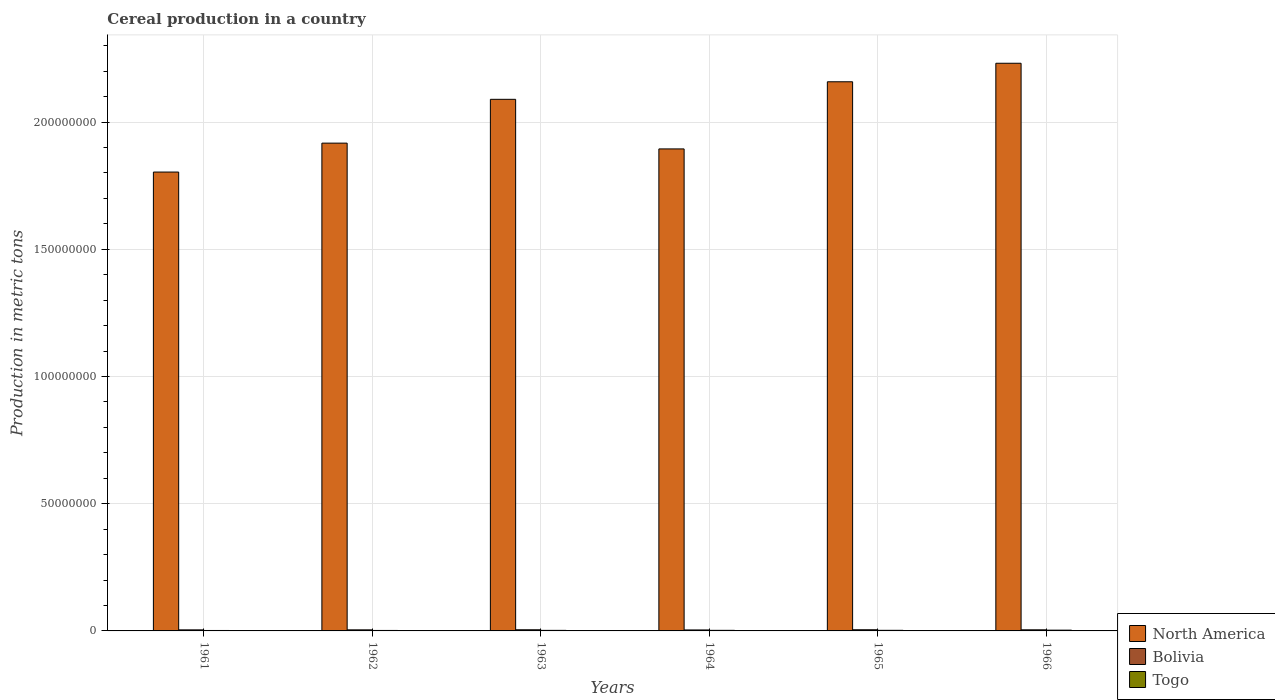How many different coloured bars are there?
Provide a succinct answer. 3. How many groups of bars are there?
Offer a terse response. 6. How many bars are there on the 4th tick from the left?
Ensure brevity in your answer.  3. How many bars are there on the 4th tick from the right?
Offer a very short reply. 3. In how many cases, is the number of bars for a given year not equal to the number of legend labels?
Offer a very short reply. 0. What is the total cereal production in Togo in 1966?
Give a very brief answer. 3.03e+05. Across all years, what is the maximum total cereal production in North America?
Offer a very short reply. 2.23e+08. Across all years, what is the minimum total cereal production in Bolivia?
Provide a succinct answer. 3.81e+05. In which year was the total cereal production in Bolivia maximum?
Keep it short and to the point. 1965. In which year was the total cereal production in Bolivia minimum?
Offer a terse response. 1964. What is the total total cereal production in North America in the graph?
Offer a very short reply. 1.21e+09. What is the difference between the total cereal production in Togo in 1965 and that in 1966?
Keep it short and to the point. -6.55e+04. What is the difference between the total cereal production in North America in 1965 and the total cereal production in Togo in 1962?
Offer a terse response. 2.16e+08. What is the average total cereal production in Togo per year?
Provide a succinct answer. 2.25e+05. In the year 1962, what is the difference between the total cereal production in Bolivia and total cereal production in Togo?
Offer a terse response. 2.33e+05. In how many years, is the total cereal production in North America greater than 110000000 metric tons?
Your answer should be compact. 6. What is the ratio of the total cereal production in Togo in 1963 to that in 1964?
Your answer should be very brief. 0.97. Is the total cereal production in North America in 1961 less than that in 1964?
Your response must be concise. Yes. What is the difference between the highest and the second highest total cereal production in Togo?
Your answer should be compact. 6.55e+04. What is the difference between the highest and the lowest total cereal production in North America?
Your response must be concise. 4.28e+07. Is the sum of the total cereal production in North America in 1961 and 1962 greater than the maximum total cereal production in Togo across all years?
Offer a terse response. Yes. What does the 3rd bar from the left in 1966 represents?
Offer a terse response. Togo. Is it the case that in every year, the sum of the total cereal production in North America and total cereal production in Togo is greater than the total cereal production in Bolivia?
Offer a very short reply. Yes. Are all the bars in the graph horizontal?
Provide a short and direct response. No. Are the values on the major ticks of Y-axis written in scientific E-notation?
Make the answer very short. No. How many legend labels are there?
Make the answer very short. 3. What is the title of the graph?
Provide a succinct answer. Cereal production in a country. What is the label or title of the X-axis?
Give a very brief answer. Years. What is the label or title of the Y-axis?
Offer a very short reply. Production in metric tons. What is the Production in metric tons of North America in 1961?
Your response must be concise. 1.80e+08. What is the Production in metric tons in Bolivia in 1961?
Your response must be concise. 4.11e+05. What is the Production in metric tons of Togo in 1961?
Provide a short and direct response. 1.74e+05. What is the Production in metric tons in North America in 1962?
Offer a very short reply. 1.92e+08. What is the Production in metric tons of Bolivia in 1962?
Keep it short and to the point. 4.18e+05. What is the Production in metric tons of Togo in 1962?
Make the answer very short. 1.86e+05. What is the Production in metric tons in North America in 1963?
Your answer should be very brief. 2.09e+08. What is the Production in metric tons of Bolivia in 1963?
Offer a very short reply. 4.50e+05. What is the Production in metric tons of Togo in 1963?
Provide a short and direct response. 2.20e+05. What is the Production in metric tons in North America in 1964?
Offer a very short reply. 1.89e+08. What is the Production in metric tons of Bolivia in 1964?
Keep it short and to the point. 3.81e+05. What is the Production in metric tons of Togo in 1964?
Your response must be concise. 2.28e+05. What is the Production in metric tons in North America in 1965?
Keep it short and to the point. 2.16e+08. What is the Production in metric tons in Bolivia in 1965?
Provide a short and direct response. 4.55e+05. What is the Production in metric tons of Togo in 1965?
Offer a terse response. 2.37e+05. What is the Production in metric tons of North America in 1966?
Make the answer very short. 2.23e+08. What is the Production in metric tons in Bolivia in 1966?
Provide a succinct answer. 4.35e+05. What is the Production in metric tons in Togo in 1966?
Your answer should be compact. 3.03e+05. Across all years, what is the maximum Production in metric tons in North America?
Make the answer very short. 2.23e+08. Across all years, what is the maximum Production in metric tons in Bolivia?
Provide a short and direct response. 4.55e+05. Across all years, what is the maximum Production in metric tons in Togo?
Offer a terse response. 3.03e+05. Across all years, what is the minimum Production in metric tons of North America?
Your response must be concise. 1.80e+08. Across all years, what is the minimum Production in metric tons of Bolivia?
Offer a terse response. 3.81e+05. Across all years, what is the minimum Production in metric tons in Togo?
Your answer should be compact. 1.74e+05. What is the total Production in metric tons in North America in the graph?
Provide a succinct answer. 1.21e+09. What is the total Production in metric tons of Bolivia in the graph?
Your response must be concise. 2.55e+06. What is the total Production in metric tons of Togo in the graph?
Ensure brevity in your answer.  1.35e+06. What is the difference between the Production in metric tons in North America in 1961 and that in 1962?
Give a very brief answer. -1.14e+07. What is the difference between the Production in metric tons in Bolivia in 1961 and that in 1962?
Offer a very short reply. -6851. What is the difference between the Production in metric tons of Togo in 1961 and that in 1962?
Your answer should be compact. -1.16e+04. What is the difference between the Production in metric tons of North America in 1961 and that in 1963?
Give a very brief answer. -2.86e+07. What is the difference between the Production in metric tons of Bolivia in 1961 and that in 1963?
Give a very brief answer. -3.80e+04. What is the difference between the Production in metric tons in Togo in 1961 and that in 1963?
Offer a very short reply. -4.57e+04. What is the difference between the Production in metric tons in North America in 1961 and that in 1964?
Your answer should be very brief. -9.09e+06. What is the difference between the Production in metric tons in Bolivia in 1961 and that in 1964?
Keep it short and to the point. 3.01e+04. What is the difference between the Production in metric tons of Togo in 1961 and that in 1964?
Make the answer very short. -5.36e+04. What is the difference between the Production in metric tons in North America in 1961 and that in 1965?
Provide a short and direct response. -3.55e+07. What is the difference between the Production in metric tons in Bolivia in 1961 and that in 1965?
Give a very brief answer. -4.36e+04. What is the difference between the Production in metric tons of Togo in 1961 and that in 1965?
Provide a succinct answer. -6.36e+04. What is the difference between the Production in metric tons in North America in 1961 and that in 1966?
Your response must be concise. -4.28e+07. What is the difference between the Production in metric tons of Bolivia in 1961 and that in 1966?
Provide a succinct answer. -2.31e+04. What is the difference between the Production in metric tons of Togo in 1961 and that in 1966?
Give a very brief answer. -1.29e+05. What is the difference between the Production in metric tons in North America in 1962 and that in 1963?
Your response must be concise. -1.72e+07. What is the difference between the Production in metric tons in Bolivia in 1962 and that in 1963?
Offer a very short reply. -3.12e+04. What is the difference between the Production in metric tons in Togo in 1962 and that in 1963?
Make the answer very short. -3.41e+04. What is the difference between the Production in metric tons of North America in 1962 and that in 1964?
Make the answer very short. 2.28e+06. What is the difference between the Production in metric tons of Bolivia in 1962 and that in 1964?
Keep it short and to the point. 3.69e+04. What is the difference between the Production in metric tons in Togo in 1962 and that in 1964?
Ensure brevity in your answer.  -4.20e+04. What is the difference between the Production in metric tons of North America in 1962 and that in 1965?
Offer a very short reply. -2.41e+07. What is the difference between the Production in metric tons in Bolivia in 1962 and that in 1965?
Your answer should be compact. -3.68e+04. What is the difference between the Production in metric tons of Togo in 1962 and that in 1965?
Make the answer very short. -5.20e+04. What is the difference between the Production in metric tons of North America in 1962 and that in 1966?
Your response must be concise. -3.14e+07. What is the difference between the Production in metric tons in Bolivia in 1962 and that in 1966?
Offer a terse response. -1.62e+04. What is the difference between the Production in metric tons in Togo in 1962 and that in 1966?
Provide a succinct answer. -1.17e+05. What is the difference between the Production in metric tons in North America in 1963 and that in 1964?
Keep it short and to the point. 1.95e+07. What is the difference between the Production in metric tons of Bolivia in 1963 and that in 1964?
Provide a succinct answer. 6.81e+04. What is the difference between the Production in metric tons of Togo in 1963 and that in 1964?
Provide a succinct answer. -7858. What is the difference between the Production in metric tons of North America in 1963 and that in 1965?
Your answer should be very brief. -6.90e+06. What is the difference between the Production in metric tons of Bolivia in 1963 and that in 1965?
Make the answer very short. -5599. What is the difference between the Production in metric tons in Togo in 1963 and that in 1965?
Offer a very short reply. -1.78e+04. What is the difference between the Production in metric tons of North America in 1963 and that in 1966?
Ensure brevity in your answer.  -1.42e+07. What is the difference between the Production in metric tons in Bolivia in 1963 and that in 1966?
Ensure brevity in your answer.  1.49e+04. What is the difference between the Production in metric tons in Togo in 1963 and that in 1966?
Provide a short and direct response. -8.33e+04. What is the difference between the Production in metric tons in North America in 1964 and that in 1965?
Provide a short and direct response. -2.64e+07. What is the difference between the Production in metric tons of Bolivia in 1964 and that in 1965?
Offer a very short reply. -7.37e+04. What is the difference between the Production in metric tons of Togo in 1964 and that in 1965?
Make the answer very short. -9987. What is the difference between the Production in metric tons in North America in 1964 and that in 1966?
Provide a succinct answer. -3.37e+07. What is the difference between the Production in metric tons in Bolivia in 1964 and that in 1966?
Keep it short and to the point. -5.32e+04. What is the difference between the Production in metric tons of Togo in 1964 and that in 1966?
Offer a very short reply. -7.55e+04. What is the difference between the Production in metric tons of North America in 1965 and that in 1966?
Your answer should be very brief. -7.28e+06. What is the difference between the Production in metric tons of Bolivia in 1965 and that in 1966?
Your answer should be compact. 2.05e+04. What is the difference between the Production in metric tons of Togo in 1965 and that in 1966?
Your answer should be very brief. -6.55e+04. What is the difference between the Production in metric tons in North America in 1961 and the Production in metric tons in Bolivia in 1962?
Offer a very short reply. 1.80e+08. What is the difference between the Production in metric tons of North America in 1961 and the Production in metric tons of Togo in 1962?
Provide a succinct answer. 1.80e+08. What is the difference between the Production in metric tons in Bolivia in 1961 and the Production in metric tons in Togo in 1962?
Offer a terse response. 2.26e+05. What is the difference between the Production in metric tons of North America in 1961 and the Production in metric tons of Bolivia in 1963?
Your response must be concise. 1.80e+08. What is the difference between the Production in metric tons of North America in 1961 and the Production in metric tons of Togo in 1963?
Provide a short and direct response. 1.80e+08. What is the difference between the Production in metric tons of Bolivia in 1961 and the Production in metric tons of Togo in 1963?
Offer a terse response. 1.92e+05. What is the difference between the Production in metric tons of North America in 1961 and the Production in metric tons of Bolivia in 1964?
Your answer should be very brief. 1.80e+08. What is the difference between the Production in metric tons of North America in 1961 and the Production in metric tons of Togo in 1964?
Your answer should be compact. 1.80e+08. What is the difference between the Production in metric tons of Bolivia in 1961 and the Production in metric tons of Togo in 1964?
Your response must be concise. 1.84e+05. What is the difference between the Production in metric tons of North America in 1961 and the Production in metric tons of Bolivia in 1965?
Your answer should be very brief. 1.80e+08. What is the difference between the Production in metric tons in North America in 1961 and the Production in metric tons in Togo in 1965?
Offer a very short reply. 1.80e+08. What is the difference between the Production in metric tons in Bolivia in 1961 and the Production in metric tons in Togo in 1965?
Ensure brevity in your answer.  1.74e+05. What is the difference between the Production in metric tons in North America in 1961 and the Production in metric tons in Bolivia in 1966?
Provide a succinct answer. 1.80e+08. What is the difference between the Production in metric tons in North America in 1961 and the Production in metric tons in Togo in 1966?
Offer a terse response. 1.80e+08. What is the difference between the Production in metric tons of Bolivia in 1961 and the Production in metric tons of Togo in 1966?
Give a very brief answer. 1.09e+05. What is the difference between the Production in metric tons in North America in 1962 and the Production in metric tons in Bolivia in 1963?
Provide a short and direct response. 1.91e+08. What is the difference between the Production in metric tons in North America in 1962 and the Production in metric tons in Togo in 1963?
Provide a short and direct response. 1.91e+08. What is the difference between the Production in metric tons in Bolivia in 1962 and the Production in metric tons in Togo in 1963?
Your answer should be compact. 1.99e+05. What is the difference between the Production in metric tons in North America in 1962 and the Production in metric tons in Bolivia in 1964?
Offer a terse response. 1.91e+08. What is the difference between the Production in metric tons of North America in 1962 and the Production in metric tons of Togo in 1964?
Make the answer very short. 1.91e+08. What is the difference between the Production in metric tons of Bolivia in 1962 and the Production in metric tons of Togo in 1964?
Make the answer very short. 1.91e+05. What is the difference between the Production in metric tons in North America in 1962 and the Production in metric tons in Bolivia in 1965?
Your answer should be very brief. 1.91e+08. What is the difference between the Production in metric tons of North America in 1962 and the Production in metric tons of Togo in 1965?
Your answer should be compact. 1.91e+08. What is the difference between the Production in metric tons in Bolivia in 1962 and the Production in metric tons in Togo in 1965?
Keep it short and to the point. 1.81e+05. What is the difference between the Production in metric tons of North America in 1962 and the Production in metric tons of Bolivia in 1966?
Your answer should be compact. 1.91e+08. What is the difference between the Production in metric tons of North America in 1962 and the Production in metric tons of Togo in 1966?
Give a very brief answer. 1.91e+08. What is the difference between the Production in metric tons of Bolivia in 1962 and the Production in metric tons of Togo in 1966?
Keep it short and to the point. 1.15e+05. What is the difference between the Production in metric tons of North America in 1963 and the Production in metric tons of Bolivia in 1964?
Your answer should be very brief. 2.09e+08. What is the difference between the Production in metric tons of North America in 1963 and the Production in metric tons of Togo in 1964?
Your response must be concise. 2.09e+08. What is the difference between the Production in metric tons of Bolivia in 1963 and the Production in metric tons of Togo in 1964?
Provide a short and direct response. 2.22e+05. What is the difference between the Production in metric tons in North America in 1963 and the Production in metric tons in Bolivia in 1965?
Make the answer very short. 2.08e+08. What is the difference between the Production in metric tons in North America in 1963 and the Production in metric tons in Togo in 1965?
Your answer should be compact. 2.09e+08. What is the difference between the Production in metric tons of Bolivia in 1963 and the Production in metric tons of Togo in 1965?
Ensure brevity in your answer.  2.12e+05. What is the difference between the Production in metric tons of North America in 1963 and the Production in metric tons of Bolivia in 1966?
Keep it short and to the point. 2.09e+08. What is the difference between the Production in metric tons of North America in 1963 and the Production in metric tons of Togo in 1966?
Your answer should be compact. 2.09e+08. What is the difference between the Production in metric tons in Bolivia in 1963 and the Production in metric tons in Togo in 1966?
Keep it short and to the point. 1.47e+05. What is the difference between the Production in metric tons of North America in 1964 and the Production in metric tons of Bolivia in 1965?
Make the answer very short. 1.89e+08. What is the difference between the Production in metric tons of North America in 1964 and the Production in metric tons of Togo in 1965?
Ensure brevity in your answer.  1.89e+08. What is the difference between the Production in metric tons in Bolivia in 1964 and the Production in metric tons in Togo in 1965?
Your answer should be very brief. 1.44e+05. What is the difference between the Production in metric tons in North America in 1964 and the Production in metric tons in Bolivia in 1966?
Your answer should be compact. 1.89e+08. What is the difference between the Production in metric tons of North America in 1964 and the Production in metric tons of Togo in 1966?
Ensure brevity in your answer.  1.89e+08. What is the difference between the Production in metric tons of Bolivia in 1964 and the Production in metric tons of Togo in 1966?
Provide a short and direct response. 7.84e+04. What is the difference between the Production in metric tons in North America in 1965 and the Production in metric tons in Bolivia in 1966?
Your answer should be very brief. 2.15e+08. What is the difference between the Production in metric tons of North America in 1965 and the Production in metric tons of Togo in 1966?
Your response must be concise. 2.16e+08. What is the difference between the Production in metric tons of Bolivia in 1965 and the Production in metric tons of Togo in 1966?
Offer a terse response. 1.52e+05. What is the average Production in metric tons of North America per year?
Offer a very short reply. 2.02e+08. What is the average Production in metric tons in Bolivia per year?
Your answer should be compact. 4.25e+05. What is the average Production in metric tons in Togo per year?
Ensure brevity in your answer.  2.25e+05. In the year 1961, what is the difference between the Production in metric tons of North America and Production in metric tons of Bolivia?
Provide a succinct answer. 1.80e+08. In the year 1961, what is the difference between the Production in metric tons in North America and Production in metric tons in Togo?
Keep it short and to the point. 1.80e+08. In the year 1961, what is the difference between the Production in metric tons in Bolivia and Production in metric tons in Togo?
Keep it short and to the point. 2.38e+05. In the year 1962, what is the difference between the Production in metric tons in North America and Production in metric tons in Bolivia?
Make the answer very short. 1.91e+08. In the year 1962, what is the difference between the Production in metric tons in North America and Production in metric tons in Togo?
Make the answer very short. 1.92e+08. In the year 1962, what is the difference between the Production in metric tons in Bolivia and Production in metric tons in Togo?
Your answer should be very brief. 2.33e+05. In the year 1963, what is the difference between the Production in metric tons of North America and Production in metric tons of Bolivia?
Offer a very short reply. 2.08e+08. In the year 1963, what is the difference between the Production in metric tons in North America and Production in metric tons in Togo?
Offer a terse response. 2.09e+08. In the year 1963, what is the difference between the Production in metric tons in Bolivia and Production in metric tons in Togo?
Your answer should be very brief. 2.30e+05. In the year 1964, what is the difference between the Production in metric tons in North America and Production in metric tons in Bolivia?
Make the answer very short. 1.89e+08. In the year 1964, what is the difference between the Production in metric tons in North America and Production in metric tons in Togo?
Ensure brevity in your answer.  1.89e+08. In the year 1964, what is the difference between the Production in metric tons of Bolivia and Production in metric tons of Togo?
Make the answer very short. 1.54e+05. In the year 1965, what is the difference between the Production in metric tons of North America and Production in metric tons of Bolivia?
Provide a short and direct response. 2.15e+08. In the year 1965, what is the difference between the Production in metric tons in North America and Production in metric tons in Togo?
Make the answer very short. 2.16e+08. In the year 1965, what is the difference between the Production in metric tons in Bolivia and Production in metric tons in Togo?
Your answer should be compact. 2.18e+05. In the year 1966, what is the difference between the Production in metric tons in North America and Production in metric tons in Bolivia?
Provide a short and direct response. 2.23e+08. In the year 1966, what is the difference between the Production in metric tons in North America and Production in metric tons in Togo?
Your answer should be very brief. 2.23e+08. In the year 1966, what is the difference between the Production in metric tons of Bolivia and Production in metric tons of Togo?
Your response must be concise. 1.32e+05. What is the ratio of the Production in metric tons in North America in 1961 to that in 1962?
Keep it short and to the point. 0.94. What is the ratio of the Production in metric tons of Bolivia in 1961 to that in 1962?
Offer a very short reply. 0.98. What is the ratio of the Production in metric tons of Togo in 1961 to that in 1962?
Your response must be concise. 0.94. What is the ratio of the Production in metric tons in North America in 1961 to that in 1963?
Your answer should be very brief. 0.86. What is the ratio of the Production in metric tons in Bolivia in 1961 to that in 1963?
Ensure brevity in your answer.  0.92. What is the ratio of the Production in metric tons of Togo in 1961 to that in 1963?
Your response must be concise. 0.79. What is the ratio of the Production in metric tons in Bolivia in 1961 to that in 1964?
Your response must be concise. 1.08. What is the ratio of the Production in metric tons of Togo in 1961 to that in 1964?
Give a very brief answer. 0.76. What is the ratio of the Production in metric tons in North America in 1961 to that in 1965?
Your answer should be very brief. 0.84. What is the ratio of the Production in metric tons of Bolivia in 1961 to that in 1965?
Keep it short and to the point. 0.9. What is the ratio of the Production in metric tons of Togo in 1961 to that in 1965?
Provide a succinct answer. 0.73. What is the ratio of the Production in metric tons in North America in 1961 to that in 1966?
Keep it short and to the point. 0.81. What is the ratio of the Production in metric tons of Bolivia in 1961 to that in 1966?
Your response must be concise. 0.95. What is the ratio of the Production in metric tons of Togo in 1961 to that in 1966?
Offer a very short reply. 0.57. What is the ratio of the Production in metric tons of North America in 1962 to that in 1963?
Your answer should be very brief. 0.92. What is the ratio of the Production in metric tons of Bolivia in 1962 to that in 1963?
Provide a succinct answer. 0.93. What is the ratio of the Production in metric tons of Togo in 1962 to that in 1963?
Offer a very short reply. 0.84. What is the ratio of the Production in metric tons of North America in 1962 to that in 1964?
Provide a short and direct response. 1.01. What is the ratio of the Production in metric tons in Bolivia in 1962 to that in 1964?
Offer a terse response. 1.1. What is the ratio of the Production in metric tons of Togo in 1962 to that in 1964?
Give a very brief answer. 0.82. What is the ratio of the Production in metric tons of North America in 1962 to that in 1965?
Provide a short and direct response. 0.89. What is the ratio of the Production in metric tons of Bolivia in 1962 to that in 1965?
Keep it short and to the point. 0.92. What is the ratio of the Production in metric tons of Togo in 1962 to that in 1965?
Provide a succinct answer. 0.78. What is the ratio of the Production in metric tons of North America in 1962 to that in 1966?
Make the answer very short. 0.86. What is the ratio of the Production in metric tons of Bolivia in 1962 to that in 1966?
Make the answer very short. 0.96. What is the ratio of the Production in metric tons of Togo in 1962 to that in 1966?
Keep it short and to the point. 0.61. What is the ratio of the Production in metric tons in North America in 1963 to that in 1964?
Your answer should be compact. 1.1. What is the ratio of the Production in metric tons of Bolivia in 1963 to that in 1964?
Offer a terse response. 1.18. What is the ratio of the Production in metric tons in Togo in 1963 to that in 1964?
Make the answer very short. 0.97. What is the ratio of the Production in metric tons of North America in 1963 to that in 1965?
Give a very brief answer. 0.97. What is the ratio of the Production in metric tons of Bolivia in 1963 to that in 1965?
Ensure brevity in your answer.  0.99. What is the ratio of the Production in metric tons in Togo in 1963 to that in 1965?
Provide a short and direct response. 0.92. What is the ratio of the Production in metric tons of North America in 1963 to that in 1966?
Your response must be concise. 0.94. What is the ratio of the Production in metric tons in Bolivia in 1963 to that in 1966?
Give a very brief answer. 1.03. What is the ratio of the Production in metric tons of Togo in 1963 to that in 1966?
Your response must be concise. 0.72. What is the ratio of the Production in metric tons of North America in 1964 to that in 1965?
Your response must be concise. 0.88. What is the ratio of the Production in metric tons in Bolivia in 1964 to that in 1965?
Give a very brief answer. 0.84. What is the ratio of the Production in metric tons in Togo in 1964 to that in 1965?
Your answer should be compact. 0.96. What is the ratio of the Production in metric tons in North America in 1964 to that in 1966?
Ensure brevity in your answer.  0.85. What is the ratio of the Production in metric tons of Bolivia in 1964 to that in 1966?
Your answer should be very brief. 0.88. What is the ratio of the Production in metric tons of Togo in 1964 to that in 1966?
Keep it short and to the point. 0.75. What is the ratio of the Production in metric tons in North America in 1965 to that in 1966?
Ensure brevity in your answer.  0.97. What is the ratio of the Production in metric tons of Bolivia in 1965 to that in 1966?
Provide a short and direct response. 1.05. What is the ratio of the Production in metric tons in Togo in 1965 to that in 1966?
Ensure brevity in your answer.  0.78. What is the difference between the highest and the second highest Production in metric tons in North America?
Offer a terse response. 7.28e+06. What is the difference between the highest and the second highest Production in metric tons of Bolivia?
Keep it short and to the point. 5599. What is the difference between the highest and the second highest Production in metric tons in Togo?
Your response must be concise. 6.55e+04. What is the difference between the highest and the lowest Production in metric tons in North America?
Offer a terse response. 4.28e+07. What is the difference between the highest and the lowest Production in metric tons in Bolivia?
Offer a terse response. 7.37e+04. What is the difference between the highest and the lowest Production in metric tons of Togo?
Your answer should be very brief. 1.29e+05. 